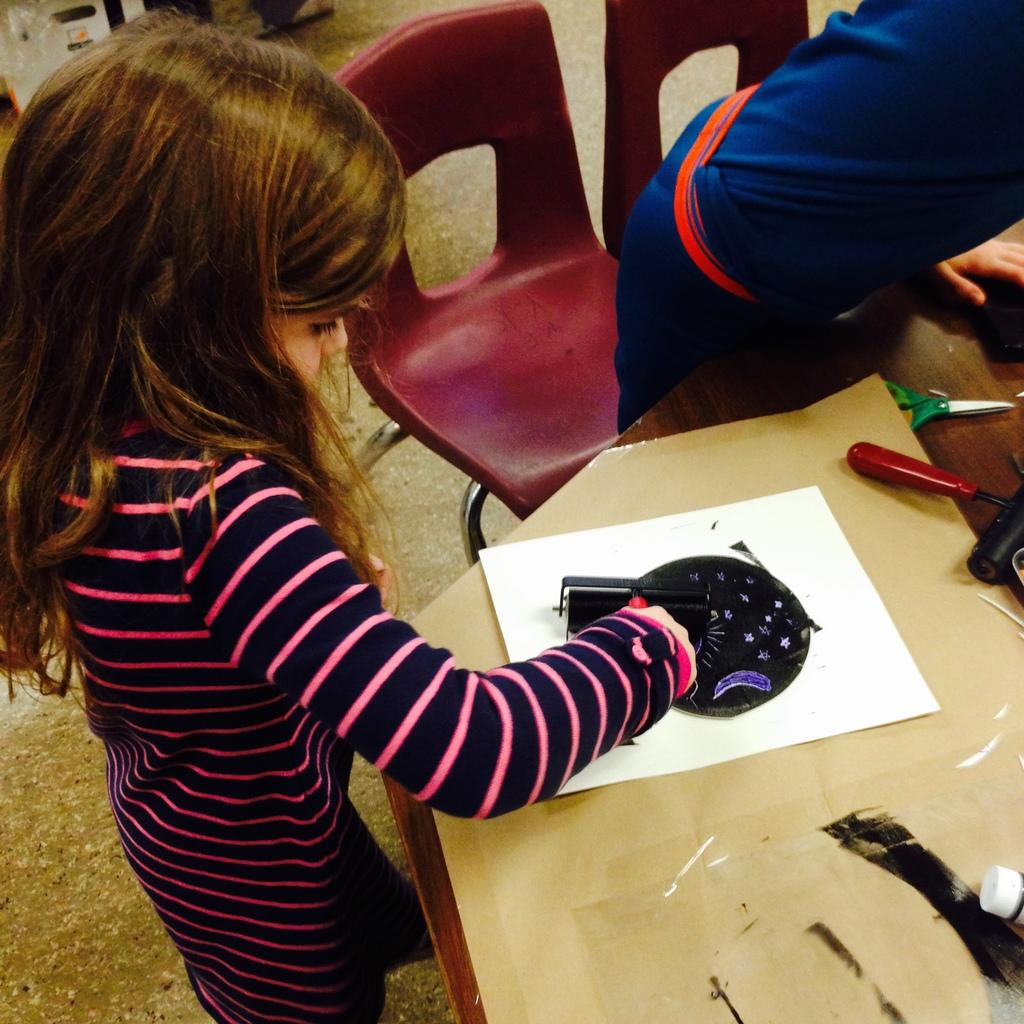What can be seen in the image involving children? There are children standing in the image. What is present on the table in the image? There is a table in the image with a paper and a pair of scissors on it. Is there any furniture visible in the image? Yes, there is a chair in the image. What type of pain can be seen on the children's faces in the image? There is no indication of pain on the children's faces in the image. What kind of silk material is draped over the table in the image? There is no silk material present in the image; it only features a table, paper, and pair of scissors. 